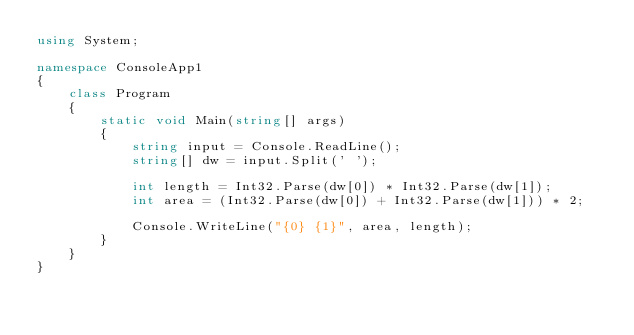<code> <loc_0><loc_0><loc_500><loc_500><_C#_>using System;

namespace ConsoleApp1
{
    class Program
    {
        static void Main(string[] args)
        {
            string input = Console.ReadLine();
            string[] dw = input.Split(' ');

            int length = Int32.Parse(dw[0]) * Int32.Parse(dw[1]);
            int area = (Int32.Parse(dw[0]) + Int32.Parse(dw[1])) * 2;

            Console.WriteLine("{0} {1}", area, length);
        }
    }
}

</code> 